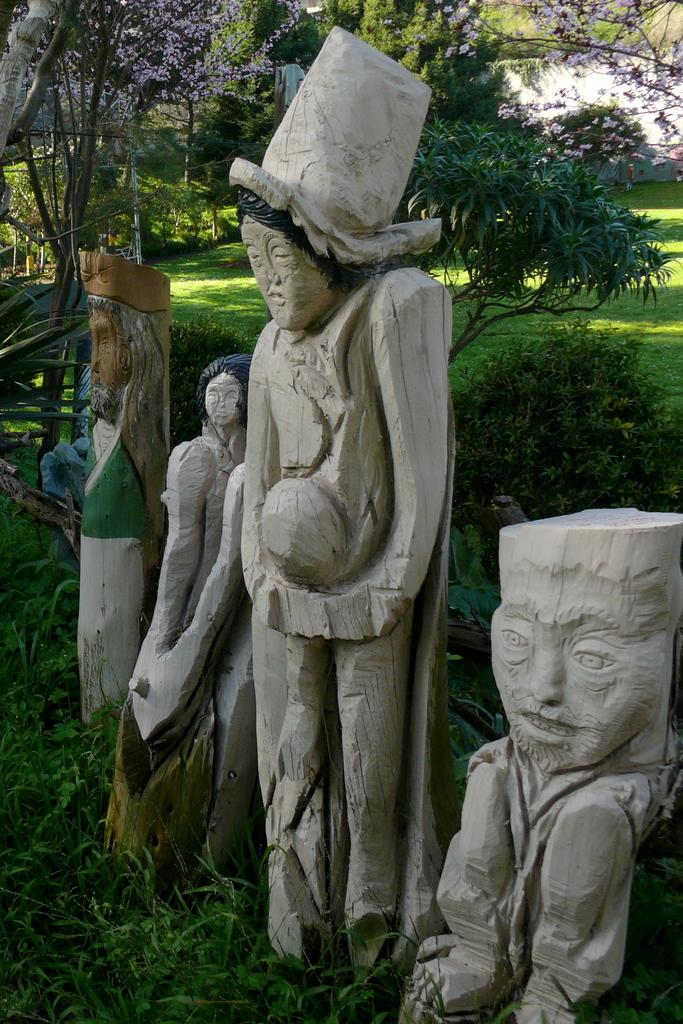What type of objects can be seen in the image? There are statues in the image. What can be seen in the background of the image? There are trees, plants, and grass in the background of the image. What type of bushes can be seen in the image? There are no bushes mentioned or visible in the image. What discovery was made by the statues in the image? The statues are not depicted as making any discoveries in the image. 